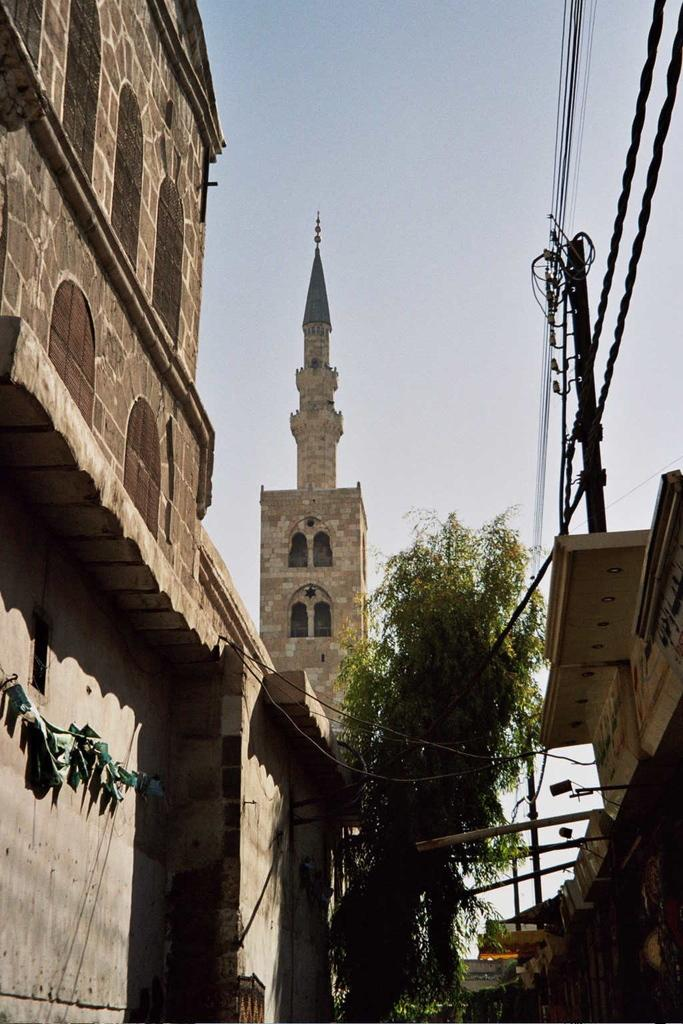What type of structure is present in the image? There is a building in the image. What natural element can be seen in the image? There is a tree in the image. What utility infrastructure is visible in the image? There is a current pole with current wires in the image. What architectural feature is present on the tower in the image? There is a tower with a spire in the image. What type of shirt is hanging on the tree in the image? There is no shirt hanging on the tree in the image. How much butter is present on the current wires in the image? There is no butter present on the current wires in the image. 